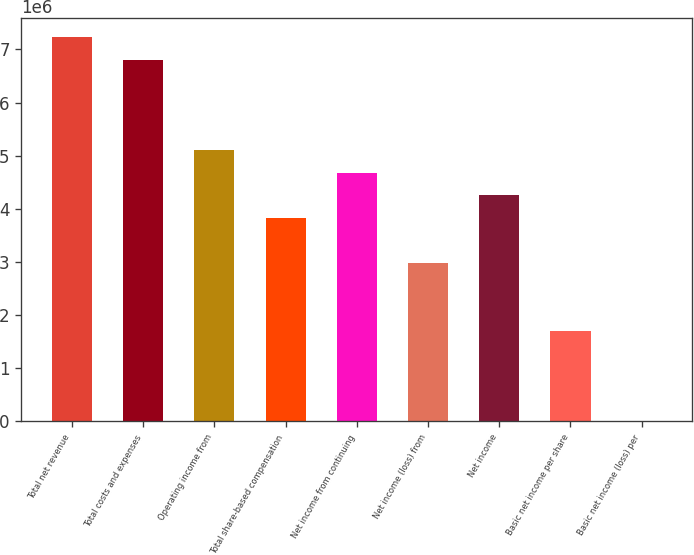<chart> <loc_0><loc_0><loc_500><loc_500><bar_chart><fcel>Total net revenue<fcel>Total costs and expenses<fcel>Operating income from<fcel>Total share-based compensation<fcel>Net income from continuing<fcel>Net income (loss) from<fcel>Net income<fcel>Basic net income per share<fcel>Basic net income (loss) per<nl><fcel>7.22844e+06<fcel>6.80324e+06<fcel>5.10243e+06<fcel>3.82682e+06<fcel>4.67723e+06<fcel>2.97642e+06<fcel>4.25203e+06<fcel>1.70081e+06<fcel>0.01<nl></chart> 